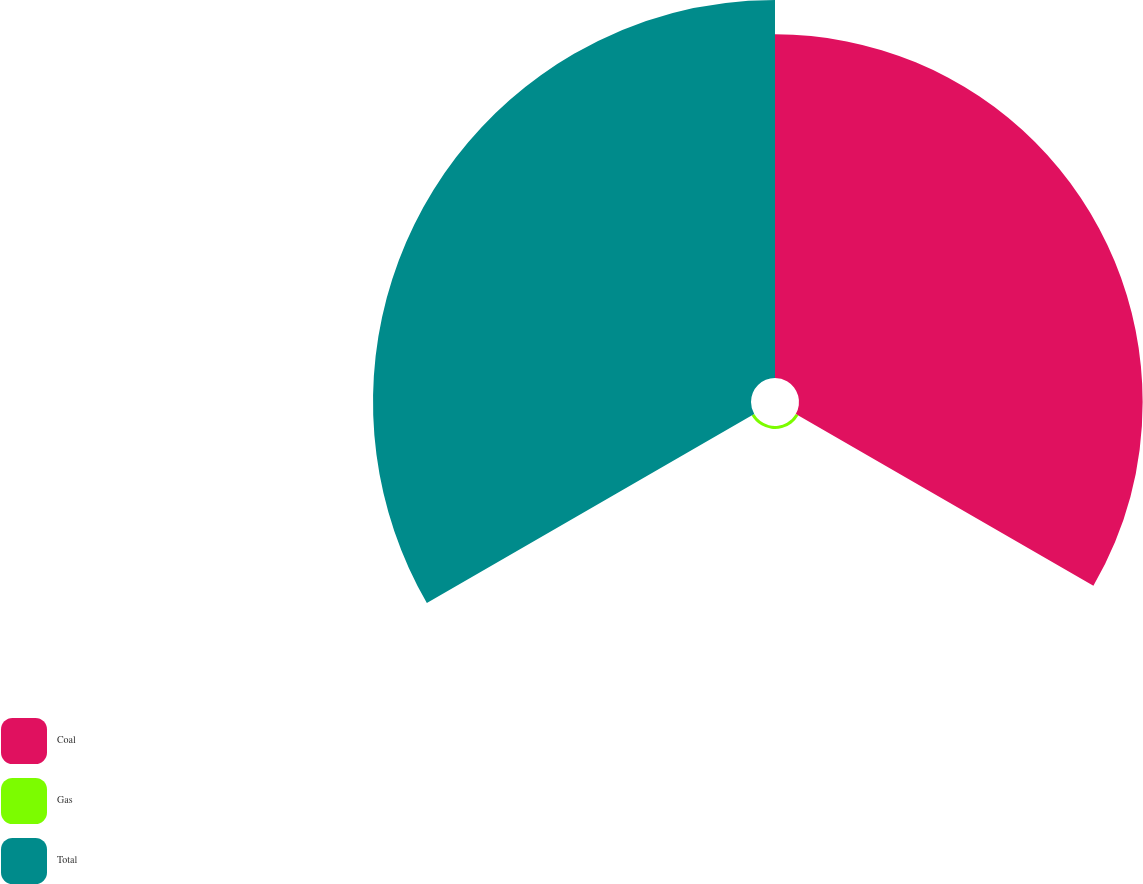<chart> <loc_0><loc_0><loc_500><loc_500><pie_chart><fcel>Coal<fcel>Gas<fcel>Total<nl><fcel>47.43%<fcel>0.41%<fcel>52.17%<nl></chart> 